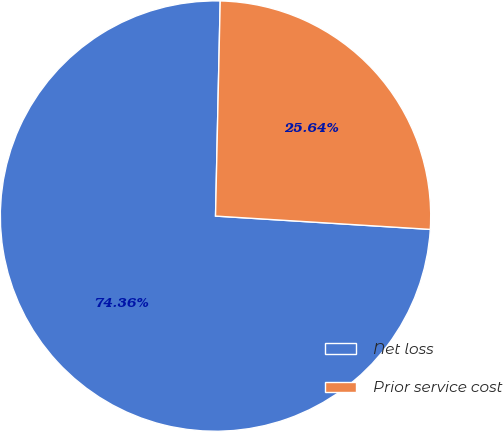Convert chart. <chart><loc_0><loc_0><loc_500><loc_500><pie_chart><fcel>Net loss<fcel>Prior service cost<nl><fcel>74.36%<fcel>25.64%<nl></chart> 